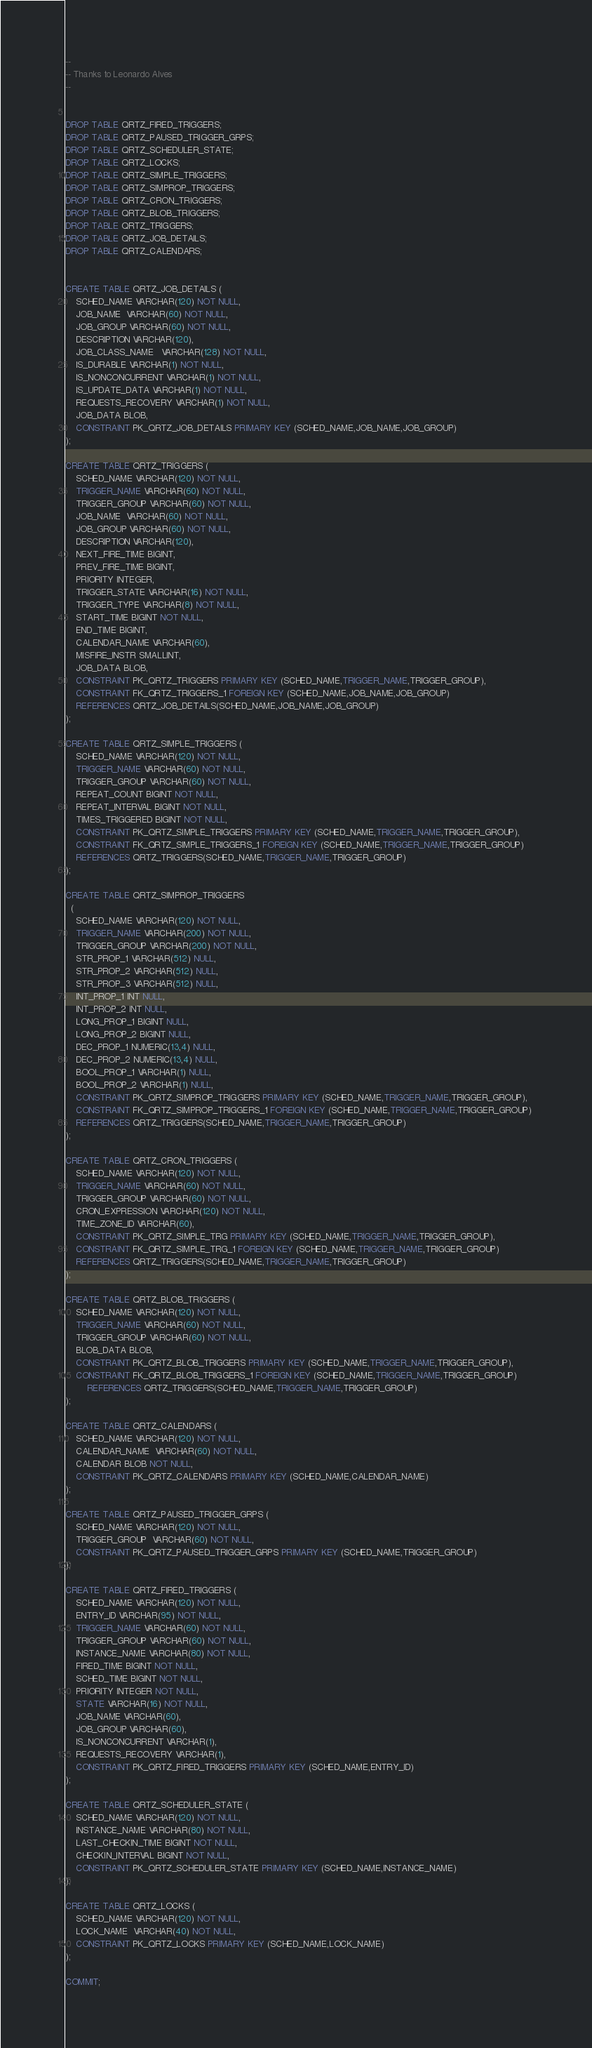<code> <loc_0><loc_0><loc_500><loc_500><_SQL_>
--
-- Thanks to Leonardo Alves
--


DROP TABLE QRTZ_FIRED_TRIGGERS;
DROP TABLE QRTZ_PAUSED_TRIGGER_GRPS;
DROP TABLE QRTZ_SCHEDULER_STATE;
DROP TABLE QRTZ_LOCKS;
DROP TABLE QRTZ_SIMPLE_TRIGGERS;
DROP TABLE QRTZ_SIMPROP_TRIGGERS;
DROP TABLE QRTZ_CRON_TRIGGERS;
DROP TABLE QRTZ_BLOB_TRIGGERS;
DROP TABLE QRTZ_TRIGGERS;
DROP TABLE QRTZ_JOB_DETAILS;
DROP TABLE QRTZ_CALENDARS;


CREATE TABLE QRTZ_JOB_DETAILS (
    SCHED_NAME VARCHAR(120) NOT NULL,
    JOB_NAME  VARCHAR(60) NOT NULL,
    JOB_GROUP VARCHAR(60) NOT NULL,
    DESCRIPTION VARCHAR(120),
    JOB_CLASS_NAME   VARCHAR(128) NOT NULL, 
    IS_DURABLE VARCHAR(1) NOT NULL,
    IS_NONCONCURRENT VARCHAR(1) NOT NULL,
    IS_UPDATE_DATA VARCHAR(1) NOT NULL,
    REQUESTS_RECOVERY VARCHAR(1) NOT NULL,
    JOB_DATA BLOB,
    CONSTRAINT PK_QRTZ_JOB_DETAILS PRIMARY KEY (SCHED_NAME,JOB_NAME,JOB_GROUP)
);

CREATE TABLE QRTZ_TRIGGERS (
    SCHED_NAME VARCHAR(120) NOT NULL,
    TRIGGER_NAME VARCHAR(60) NOT NULL,
    TRIGGER_GROUP VARCHAR(60) NOT NULL,
    JOB_NAME  VARCHAR(60) NOT NULL, 
    JOB_GROUP VARCHAR(60) NOT NULL,
    DESCRIPTION VARCHAR(120),
    NEXT_FIRE_TIME BIGINT,
    PREV_FIRE_TIME BIGINT,
    PRIORITY INTEGER,
    TRIGGER_STATE VARCHAR(16) NOT NULL,
    TRIGGER_TYPE VARCHAR(8) NOT NULL,
    START_TIME BIGINT NOT NULL,
    END_TIME BIGINT,
    CALENDAR_NAME VARCHAR(60),
    MISFIRE_INSTR SMALLINT,
    JOB_DATA BLOB,
    CONSTRAINT PK_QRTZ_TRIGGERS PRIMARY KEY (SCHED_NAME,TRIGGER_NAME,TRIGGER_GROUP),
    CONSTRAINT FK_QRTZ_TRIGGERS_1 FOREIGN KEY (SCHED_NAME,JOB_NAME,JOB_GROUP) 
    REFERENCES QRTZ_JOB_DETAILS(SCHED_NAME,JOB_NAME,JOB_GROUP) 
);

CREATE TABLE QRTZ_SIMPLE_TRIGGERS (
    SCHED_NAME VARCHAR(120) NOT NULL,
    TRIGGER_NAME VARCHAR(60) NOT NULL,
    TRIGGER_GROUP VARCHAR(60) NOT NULL,
    REPEAT_COUNT BIGINT NOT NULL,
    REPEAT_INTERVAL BIGINT NOT NULL,
    TIMES_TRIGGERED BIGINT NOT NULL,
    CONSTRAINT PK_QRTZ_SIMPLE_TRIGGERS PRIMARY KEY (SCHED_NAME,TRIGGER_NAME,TRIGGER_GROUP),
    CONSTRAINT FK_QRTZ_SIMPLE_TRIGGERS_1 FOREIGN KEY (SCHED_NAME,TRIGGER_NAME,TRIGGER_GROUP) 
    REFERENCES QRTZ_TRIGGERS(SCHED_NAME,TRIGGER_NAME,TRIGGER_GROUP)
);

CREATE TABLE QRTZ_SIMPROP_TRIGGERS
  (          
    SCHED_NAME VARCHAR(120) NOT NULL,
    TRIGGER_NAME VARCHAR(200) NOT NULL,
    TRIGGER_GROUP VARCHAR(200) NOT NULL,
    STR_PROP_1 VARCHAR(512) NULL,
    STR_PROP_2 VARCHAR(512) NULL,
    STR_PROP_3 VARCHAR(512) NULL,
    INT_PROP_1 INT NULL,
    INT_PROP_2 INT NULL,
    LONG_PROP_1 BIGINT NULL,
    LONG_PROP_2 BIGINT NULL,
    DEC_PROP_1 NUMERIC(13,4) NULL,
    DEC_PROP_2 NUMERIC(13,4) NULL,
    BOOL_PROP_1 VARCHAR(1) NULL,
    BOOL_PROP_2 VARCHAR(1) NULL,
    CONSTRAINT PK_QRTZ_SIMPROP_TRIGGERS PRIMARY KEY (SCHED_NAME,TRIGGER_NAME,TRIGGER_GROUP),
    CONSTRAINT FK_QRTZ_SIMPROP_TRIGGERS_1 FOREIGN KEY (SCHED_NAME,TRIGGER_NAME,TRIGGER_GROUP) 
    REFERENCES QRTZ_TRIGGERS(SCHED_NAME,TRIGGER_NAME,TRIGGER_GROUP)
);

CREATE TABLE QRTZ_CRON_TRIGGERS (
    SCHED_NAME VARCHAR(120) NOT NULL,
    TRIGGER_NAME VARCHAR(60) NOT NULL,
    TRIGGER_GROUP VARCHAR(60) NOT NULL,
    CRON_EXPRESSION VARCHAR(120) NOT NULL,
    TIME_ZONE_ID VARCHAR(60),
    CONSTRAINT PK_QRTZ_SIMPLE_TRG PRIMARY KEY (SCHED_NAME,TRIGGER_NAME,TRIGGER_GROUP),
    CONSTRAINT FK_QRTZ_SIMPLE_TRG_1 FOREIGN KEY (SCHED_NAME,TRIGGER_NAME,TRIGGER_GROUP)
    REFERENCES QRTZ_TRIGGERS(SCHED_NAME,TRIGGER_NAME,TRIGGER_GROUP)
);

CREATE TABLE QRTZ_BLOB_TRIGGERS (
    SCHED_NAME VARCHAR(120) NOT NULL,
    TRIGGER_NAME VARCHAR(60) NOT NULL,
    TRIGGER_GROUP VARCHAR(60) NOT NULL,
    BLOB_DATA BLOB,
    CONSTRAINT PK_QRTZ_BLOB_TRIGGERS PRIMARY KEY (SCHED_NAME,TRIGGER_NAME,TRIGGER_GROUP),
    CONSTRAINT FK_QRTZ_BLOB_TRIGGERS_1 FOREIGN KEY (SCHED_NAME,TRIGGER_NAME,TRIGGER_GROUP) 
        REFERENCES QRTZ_TRIGGERS(SCHED_NAME,TRIGGER_NAME,TRIGGER_GROUP)
);

CREATE TABLE QRTZ_CALENDARS (
    SCHED_NAME VARCHAR(120) NOT NULL,
    CALENDAR_NAME  VARCHAR(60) NOT NULL, 
    CALENDAR BLOB NOT NULL,
    CONSTRAINT PK_QRTZ_CALENDARS PRIMARY KEY (SCHED_NAME,CALENDAR_NAME)
);

CREATE TABLE QRTZ_PAUSED_TRIGGER_GRPS (
    SCHED_NAME VARCHAR(120) NOT NULL,
    TRIGGER_GROUP  VARCHAR(60) NOT NULL, 
    CONSTRAINT PK_QRTZ_PAUSED_TRIGGER_GRPS PRIMARY KEY (SCHED_NAME,TRIGGER_GROUP)
);

CREATE TABLE QRTZ_FIRED_TRIGGERS (
    SCHED_NAME VARCHAR(120) NOT NULL,
    ENTRY_ID VARCHAR(95) NOT NULL,
    TRIGGER_NAME VARCHAR(60) NOT NULL,
    TRIGGER_GROUP VARCHAR(60) NOT NULL,
    INSTANCE_NAME VARCHAR(80) NOT NULL,
    FIRED_TIME BIGINT NOT NULL,
    SCHED_TIME BIGINT NOT NULL,
    PRIORITY INTEGER NOT NULL,
    STATE VARCHAR(16) NOT NULL,
    JOB_NAME VARCHAR(60),
    JOB_GROUP VARCHAR(60),
    IS_NONCONCURRENT VARCHAR(1),
    REQUESTS_RECOVERY VARCHAR(1),
    CONSTRAINT PK_QRTZ_FIRED_TRIGGERS PRIMARY KEY (SCHED_NAME,ENTRY_ID)
);

CREATE TABLE QRTZ_SCHEDULER_STATE (
    SCHED_NAME VARCHAR(120) NOT NULL,
    INSTANCE_NAME VARCHAR(80) NOT NULL,
    LAST_CHECKIN_TIME BIGINT NOT NULL,
    CHECKIN_INTERVAL BIGINT NOT NULL,
    CONSTRAINT PK_QRTZ_SCHEDULER_STATE PRIMARY KEY (SCHED_NAME,INSTANCE_NAME)
);

CREATE TABLE QRTZ_LOCKS (
    SCHED_NAME VARCHAR(120) NOT NULL,
    LOCK_NAME  VARCHAR(40) NOT NULL, 
    CONSTRAINT PK_QRTZ_LOCKS PRIMARY KEY (SCHED_NAME,LOCK_NAME)
);

COMMIT;
</code> 